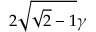Convert formula to latex. <formula><loc_0><loc_0><loc_500><loc_500>2 \sqrt { \sqrt { 2 } - 1 } \gamma</formula> 